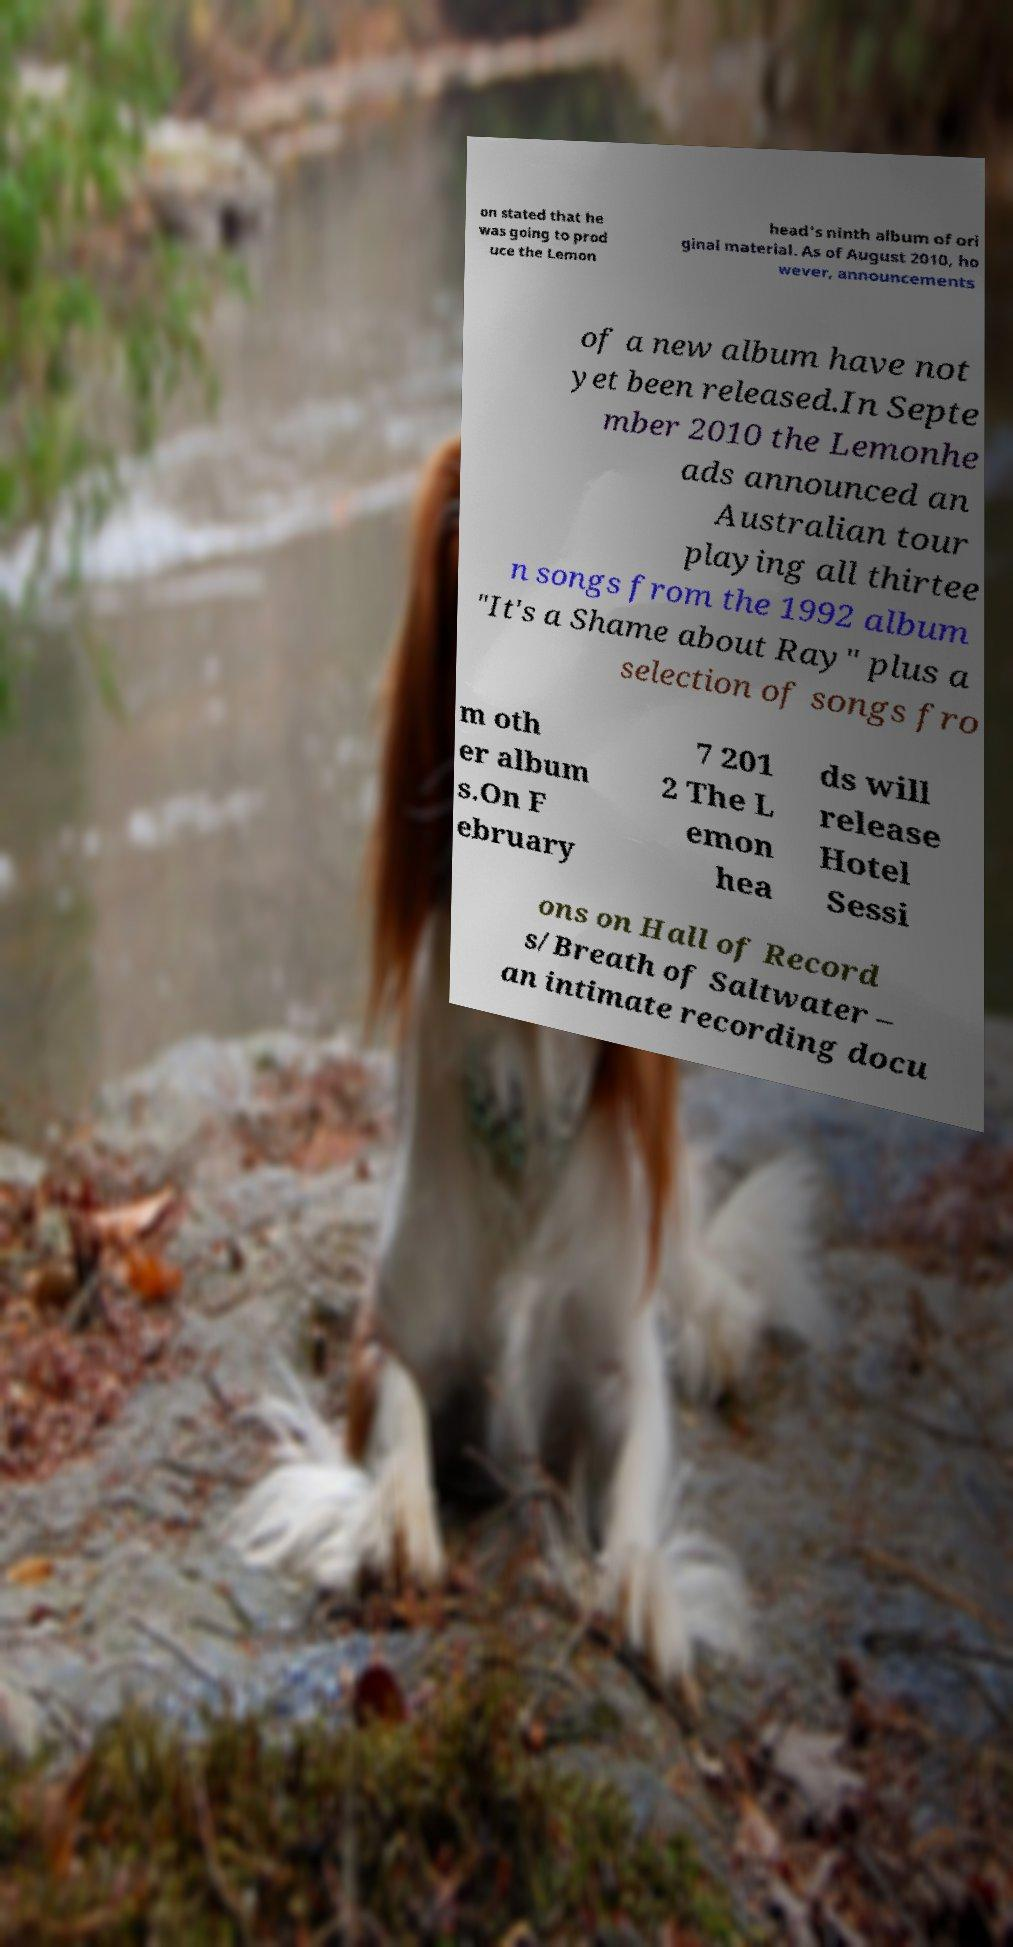What messages or text are displayed in this image? I need them in a readable, typed format. on stated that he was going to prod uce the Lemon head's ninth album of ori ginal material. As of August 2010, ho wever, announcements of a new album have not yet been released.In Septe mber 2010 the Lemonhe ads announced an Australian tour playing all thirtee n songs from the 1992 album "It's a Shame about Ray" plus a selection of songs fro m oth er album s.On F ebruary 7 201 2 The L emon hea ds will release Hotel Sessi ons on Hall of Record s/Breath of Saltwater – an intimate recording docu 